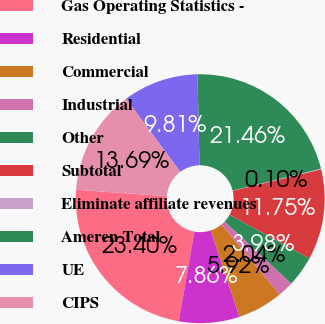<chart> <loc_0><loc_0><loc_500><loc_500><pie_chart><fcel>Gas Operating Statistics -<fcel>Residential<fcel>Commercial<fcel>Industrial<fcel>Other<fcel>Subtotal<fcel>Eliminate affiliate revenues<fcel>Ameren Total<fcel>UE<fcel>CIPS<nl><fcel>23.4%<fcel>7.86%<fcel>5.92%<fcel>2.04%<fcel>3.98%<fcel>11.75%<fcel>0.1%<fcel>21.46%<fcel>9.81%<fcel>13.69%<nl></chart> 